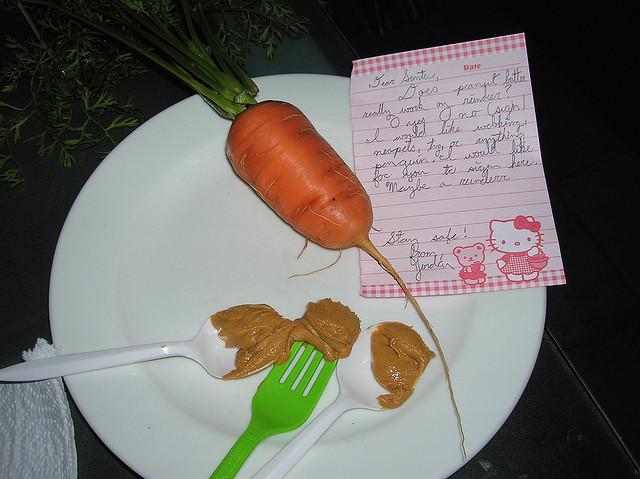How many utensils are on the plate?
Write a very short answer. 3. What character is on the paper?
Quick response, please. Hello kitty. What veggie is on the plate?
Quick response, please. Carrot. 